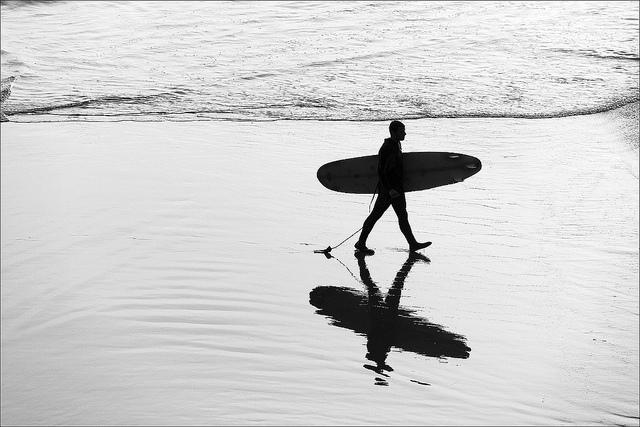What can splish splash as it walks?
Answer briefly. Man. What is the weather?
Quick response, please. Clear. Is there water?
Answer briefly. Yes. Is this photo greyscale?
Be succinct. Yes. What does the person have in their hand?
Concise answer only. Surfboard. Can you see a shadow?
Concise answer only. Yes. 